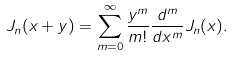<formula> <loc_0><loc_0><loc_500><loc_500>J _ { n } ( x + y ) = \sum _ { m = 0 } ^ { \infty } \frac { y ^ { m } } { m ! } \frac { d ^ { m } } { d x ^ { m } } J _ { n } ( x ) .</formula> 